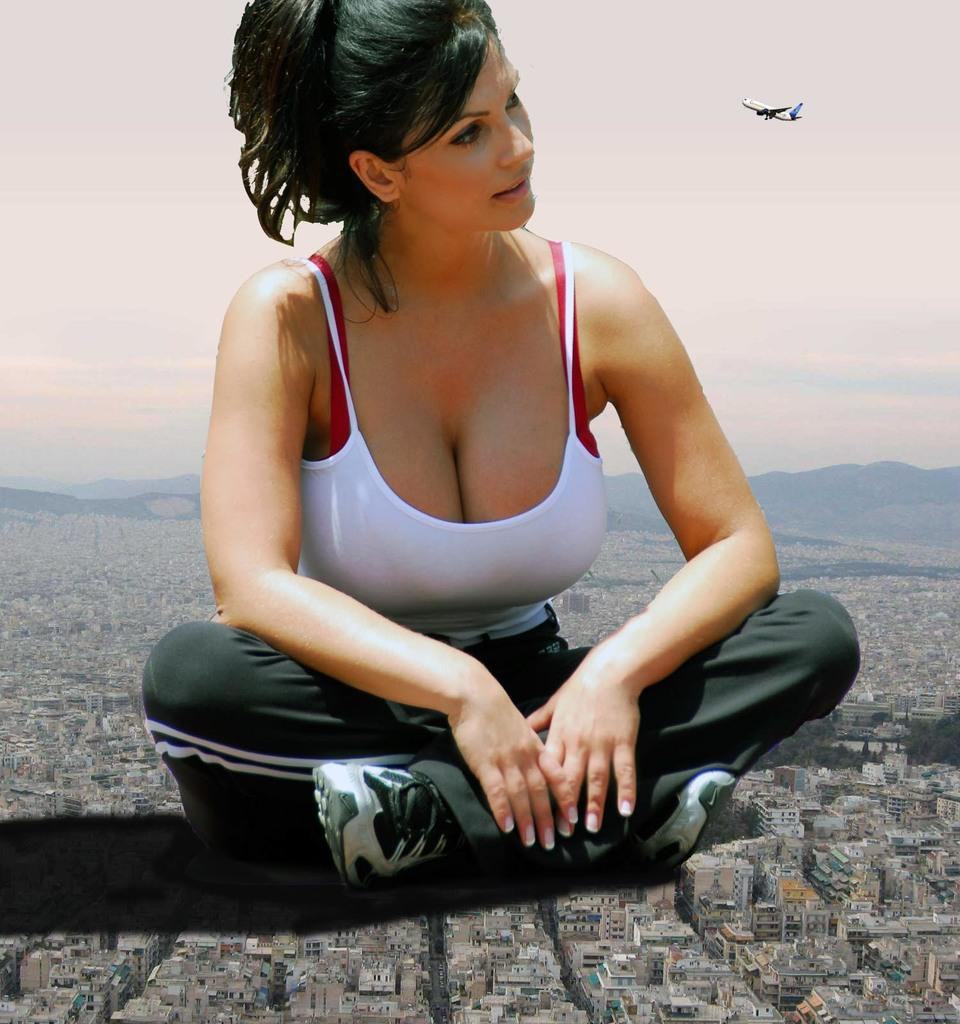Who is present in the image? There is a woman in the image. What is the woman wearing? The woman is wearing a white t-shirt. Where is the woman sitting? The woman is sitting on a building. What can be seen in the background of the image? There are buildings, mountains, and an airplane in the sky in the background of the image. What type of toys can be seen on the woman's lap in the image? There are no toys visible in the image; the woman is sitting on a building. 